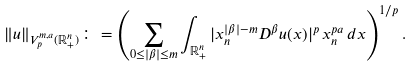Convert formula to latex. <formula><loc_0><loc_0><loc_500><loc_500>\| u \| _ { V _ { p } ^ { m , a } ( \mathbb { R } ^ { n } _ { + } ) } \colon = \left ( \sum _ { 0 \leq | \beta | \leq m } \int _ { \mathbb { R } ^ { n } _ { + } } | x _ { n } ^ { | \beta | - m } D ^ { \beta } u ( x ) | ^ { p } \, x _ { n } ^ { p a } \, d x \right ) ^ { 1 / p } .</formula> 